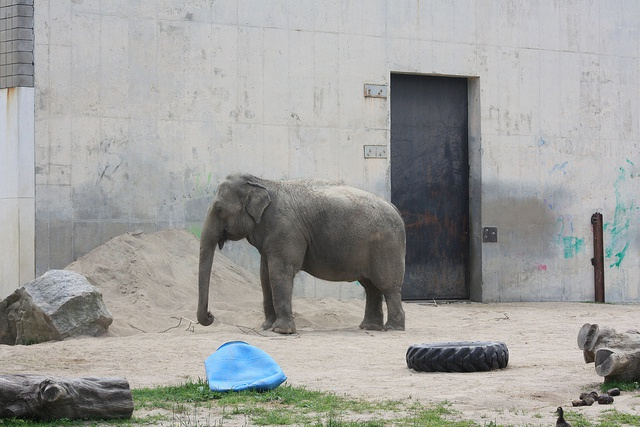Describe the objects in this image and their specific colors. I can see a elephant in gray, black, and darkgray tones in this image. 